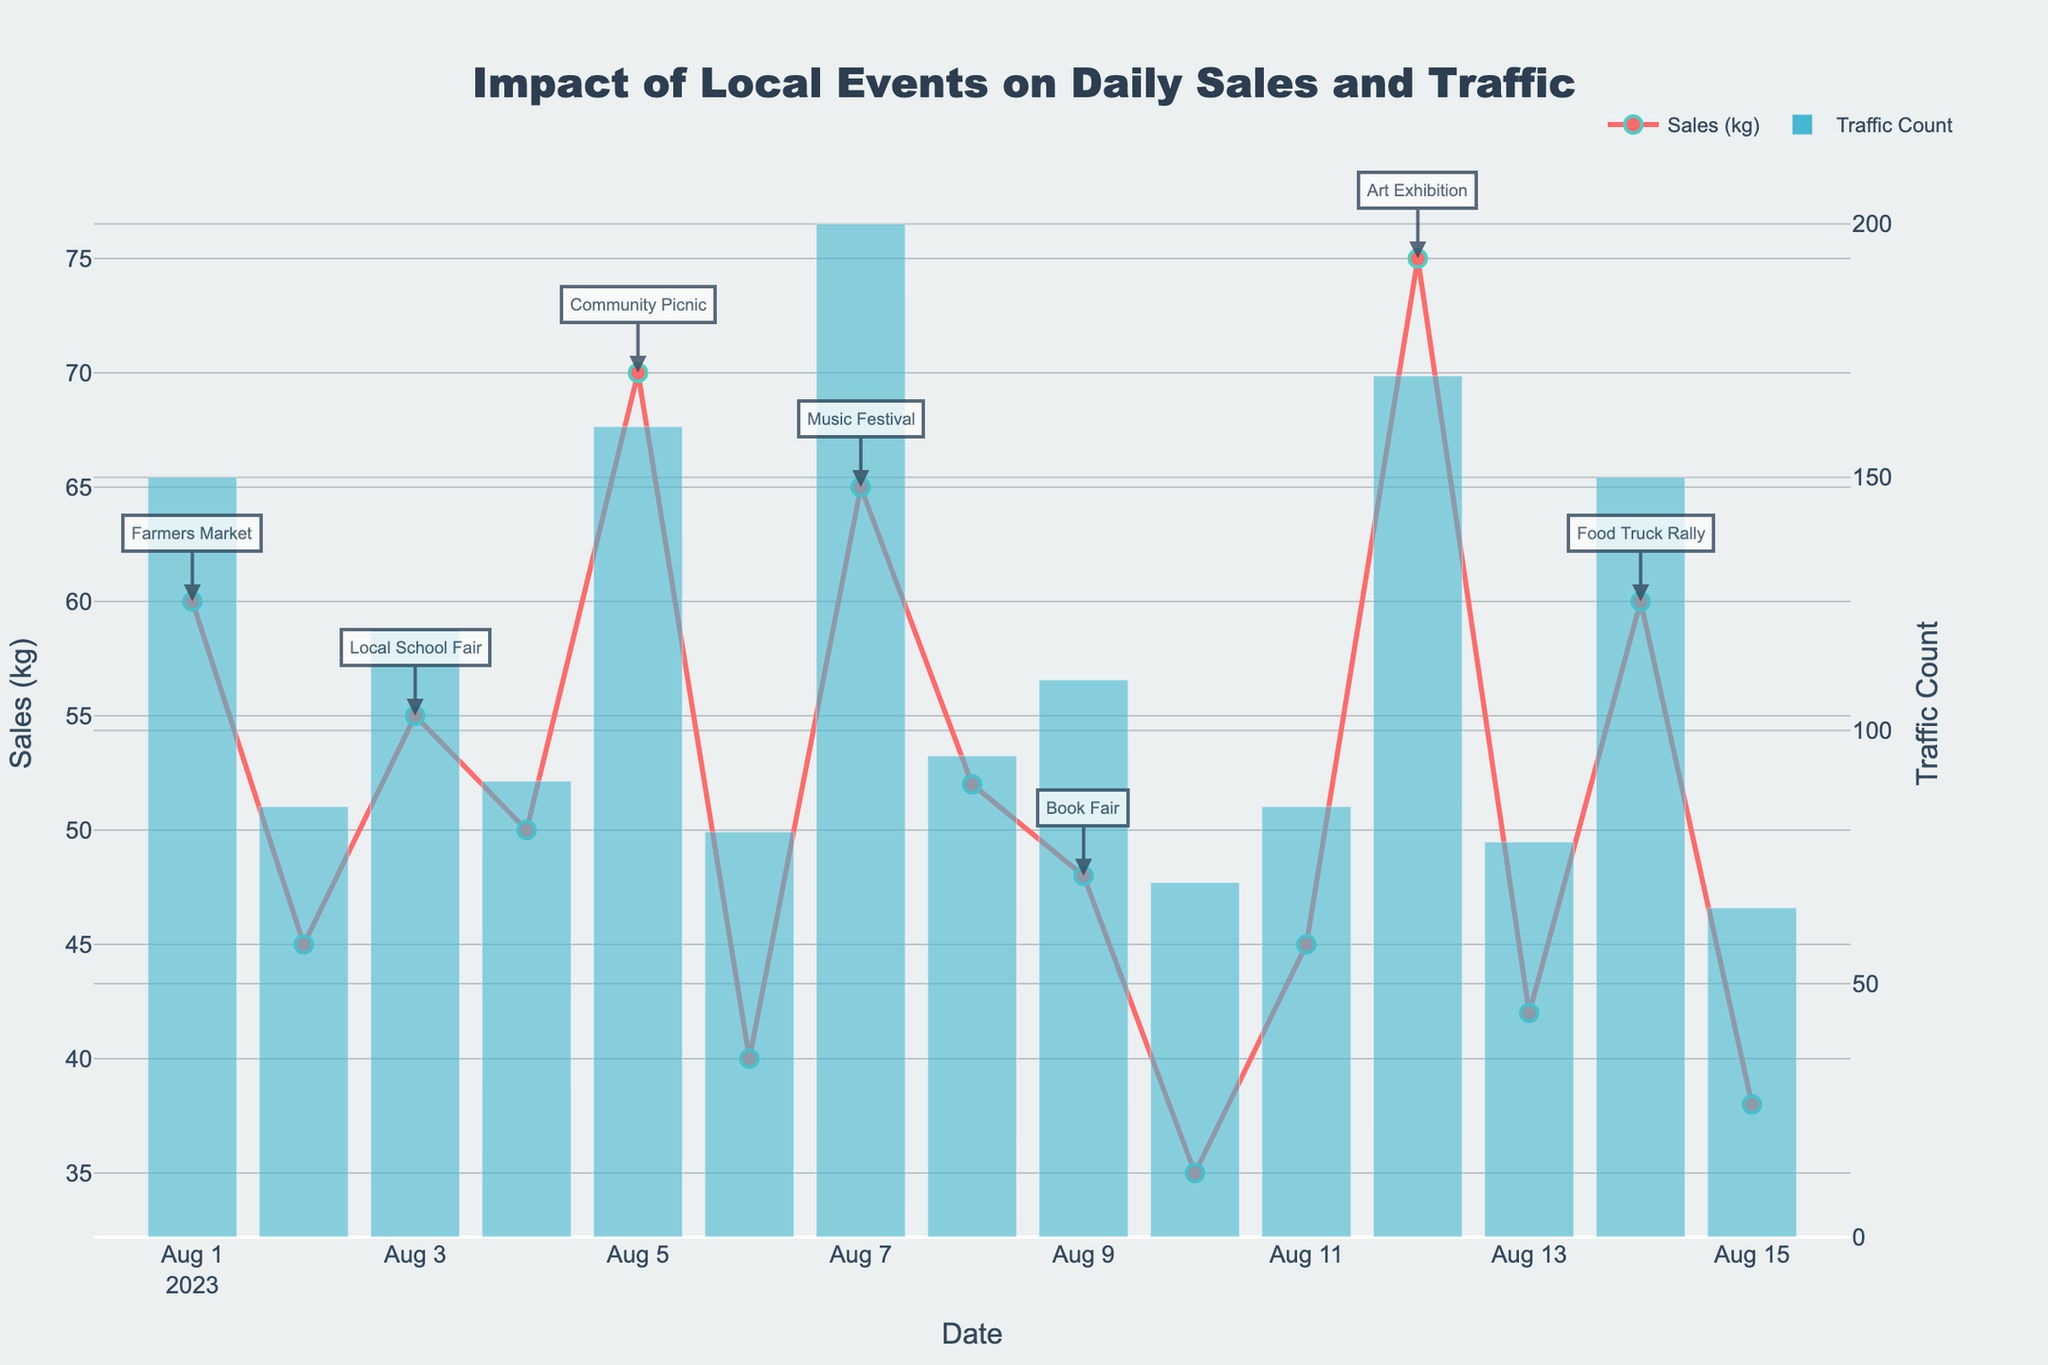What is the title of the plot? The title can be found at the top center of the plot.
Answer: Impact of Local Events on Daily Sales and Traffic How many days had an event listed? Count the number of distinct dates that have an event annotation in the plot.
Answer: 7 What was the highest daily traffic count and on which date did it occur? Identify the tallest bar for Traffic Count and note its value and corresponding date on the x-axis.
Answer: 200 on 2023-08-07 Which date had the lowest sales and what was the sales quantity? Locate the smallest point for Sales (kg) on the y-axis and note the date and the value associated with it.
Answer: 2023-08-10 with 35 kg Compare the sales on days with events to the average sales on days without events. Which is higher? List Sales (kg) values on event days and compute their average; then do the same for non-event days and compare. Event days: (60+55+70+65+48+75+60)/7 = 61 kg. Non-event days: (45+50+40+52+35+45+42+38)/8 = 43.375 kg.
Answer: Higher on event days at 61 kg What was the difference in sales between the day with the highest sales and the day with the lowest sales? Locate the highest point and the lowest point on the Sales (kg) axis, subtract the lowest value from the highest value. Highest sales: 75 kg; Lowest sales: 35 kg. Difference: 75 - 35.
Answer: 40 kg Did sales increase on event days compared to adjacent non-event days? Give one example. Compare sales on any event day to the day before and after it to check for increments. For example: Aug 1 (event) vs Jul 31 and Aug 2; Sales on Aug 1 (60) > Aug 2 (45).
Answer: Sales increased on event days compared to adjacent non-event days Were there any days where high traffic count did not correlate with high sales? Identify days with high bars on the Traffic Count axis and see if they align with high points on the Sales (kg) axis. For example: HR 'date' with traffic count but medium/low sales.
Answer: 2023-08-09, high (110) Traffic Count but moderate sales (48 kg) What trend can you observe in sales over the two-week period? Observe the general direction of points on the Sales (kg) axis from start to end of the Date axis.
Answer: Fluctuating but higher during event days Which event day had the highest sales and what were the sales? Locate the event with the highest point for Sales (kg) and note its sales value.
Answer: 2023-08-12 with 75 kg 